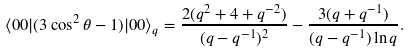<formula> <loc_0><loc_0><loc_500><loc_500>\langle 0 0 | ( 3 \cos ^ { 2 } \theta - 1 ) | 0 0 \rangle _ { q } = \frac { 2 ( q ^ { 2 } + 4 + q ^ { - 2 } ) } { ( q - q ^ { - 1 } ) ^ { 2 } } - \frac { 3 ( q + q ^ { - 1 } ) } { ( q - q ^ { - 1 } ) \ln q } .</formula> 